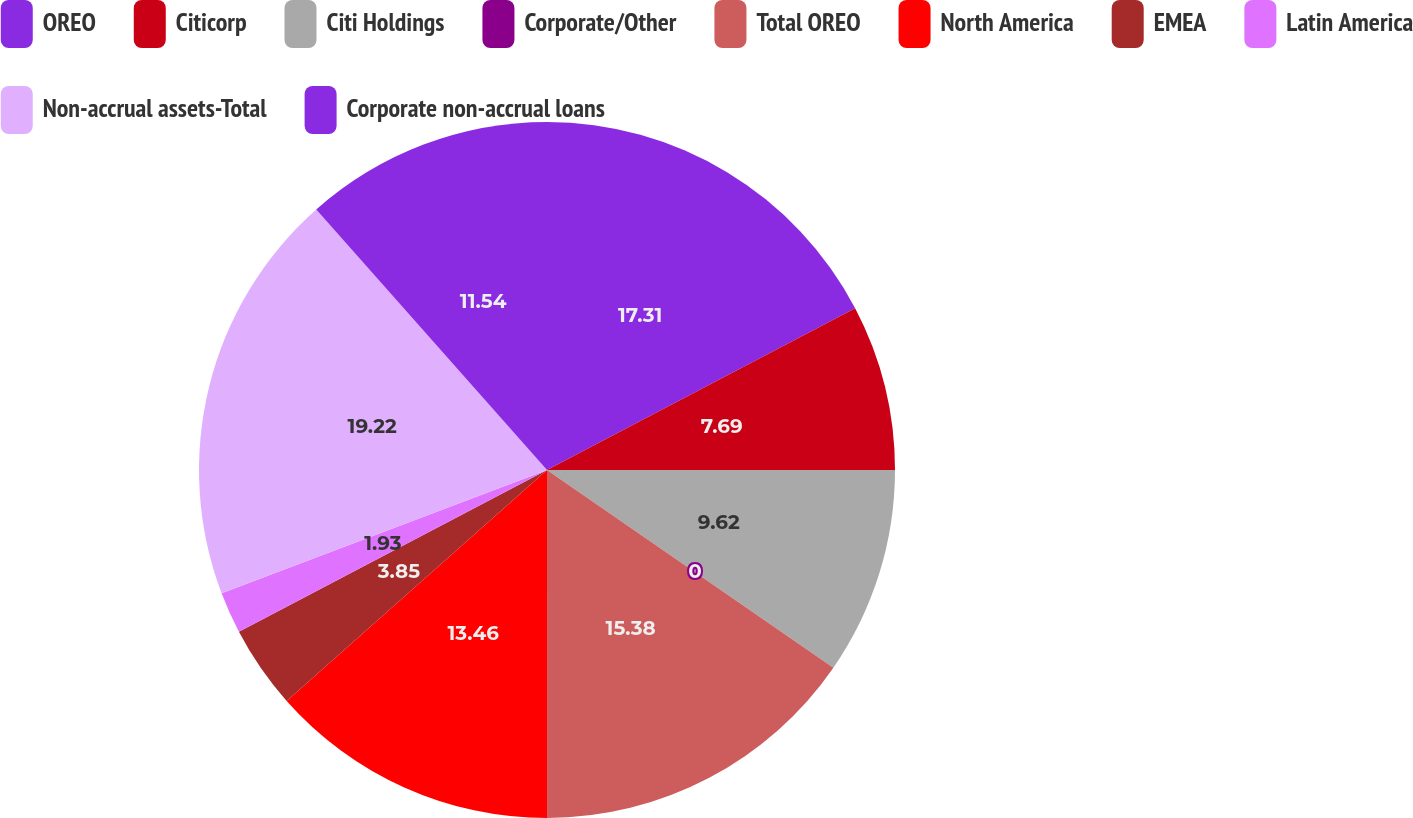<chart> <loc_0><loc_0><loc_500><loc_500><pie_chart><fcel>OREO<fcel>Citicorp<fcel>Citi Holdings<fcel>Corporate/Other<fcel>Total OREO<fcel>North America<fcel>EMEA<fcel>Latin America<fcel>Non-accrual assets-Total<fcel>Corporate non-accrual loans<nl><fcel>17.31%<fcel>7.69%<fcel>9.62%<fcel>0.0%<fcel>15.38%<fcel>13.46%<fcel>3.85%<fcel>1.93%<fcel>19.23%<fcel>11.54%<nl></chart> 